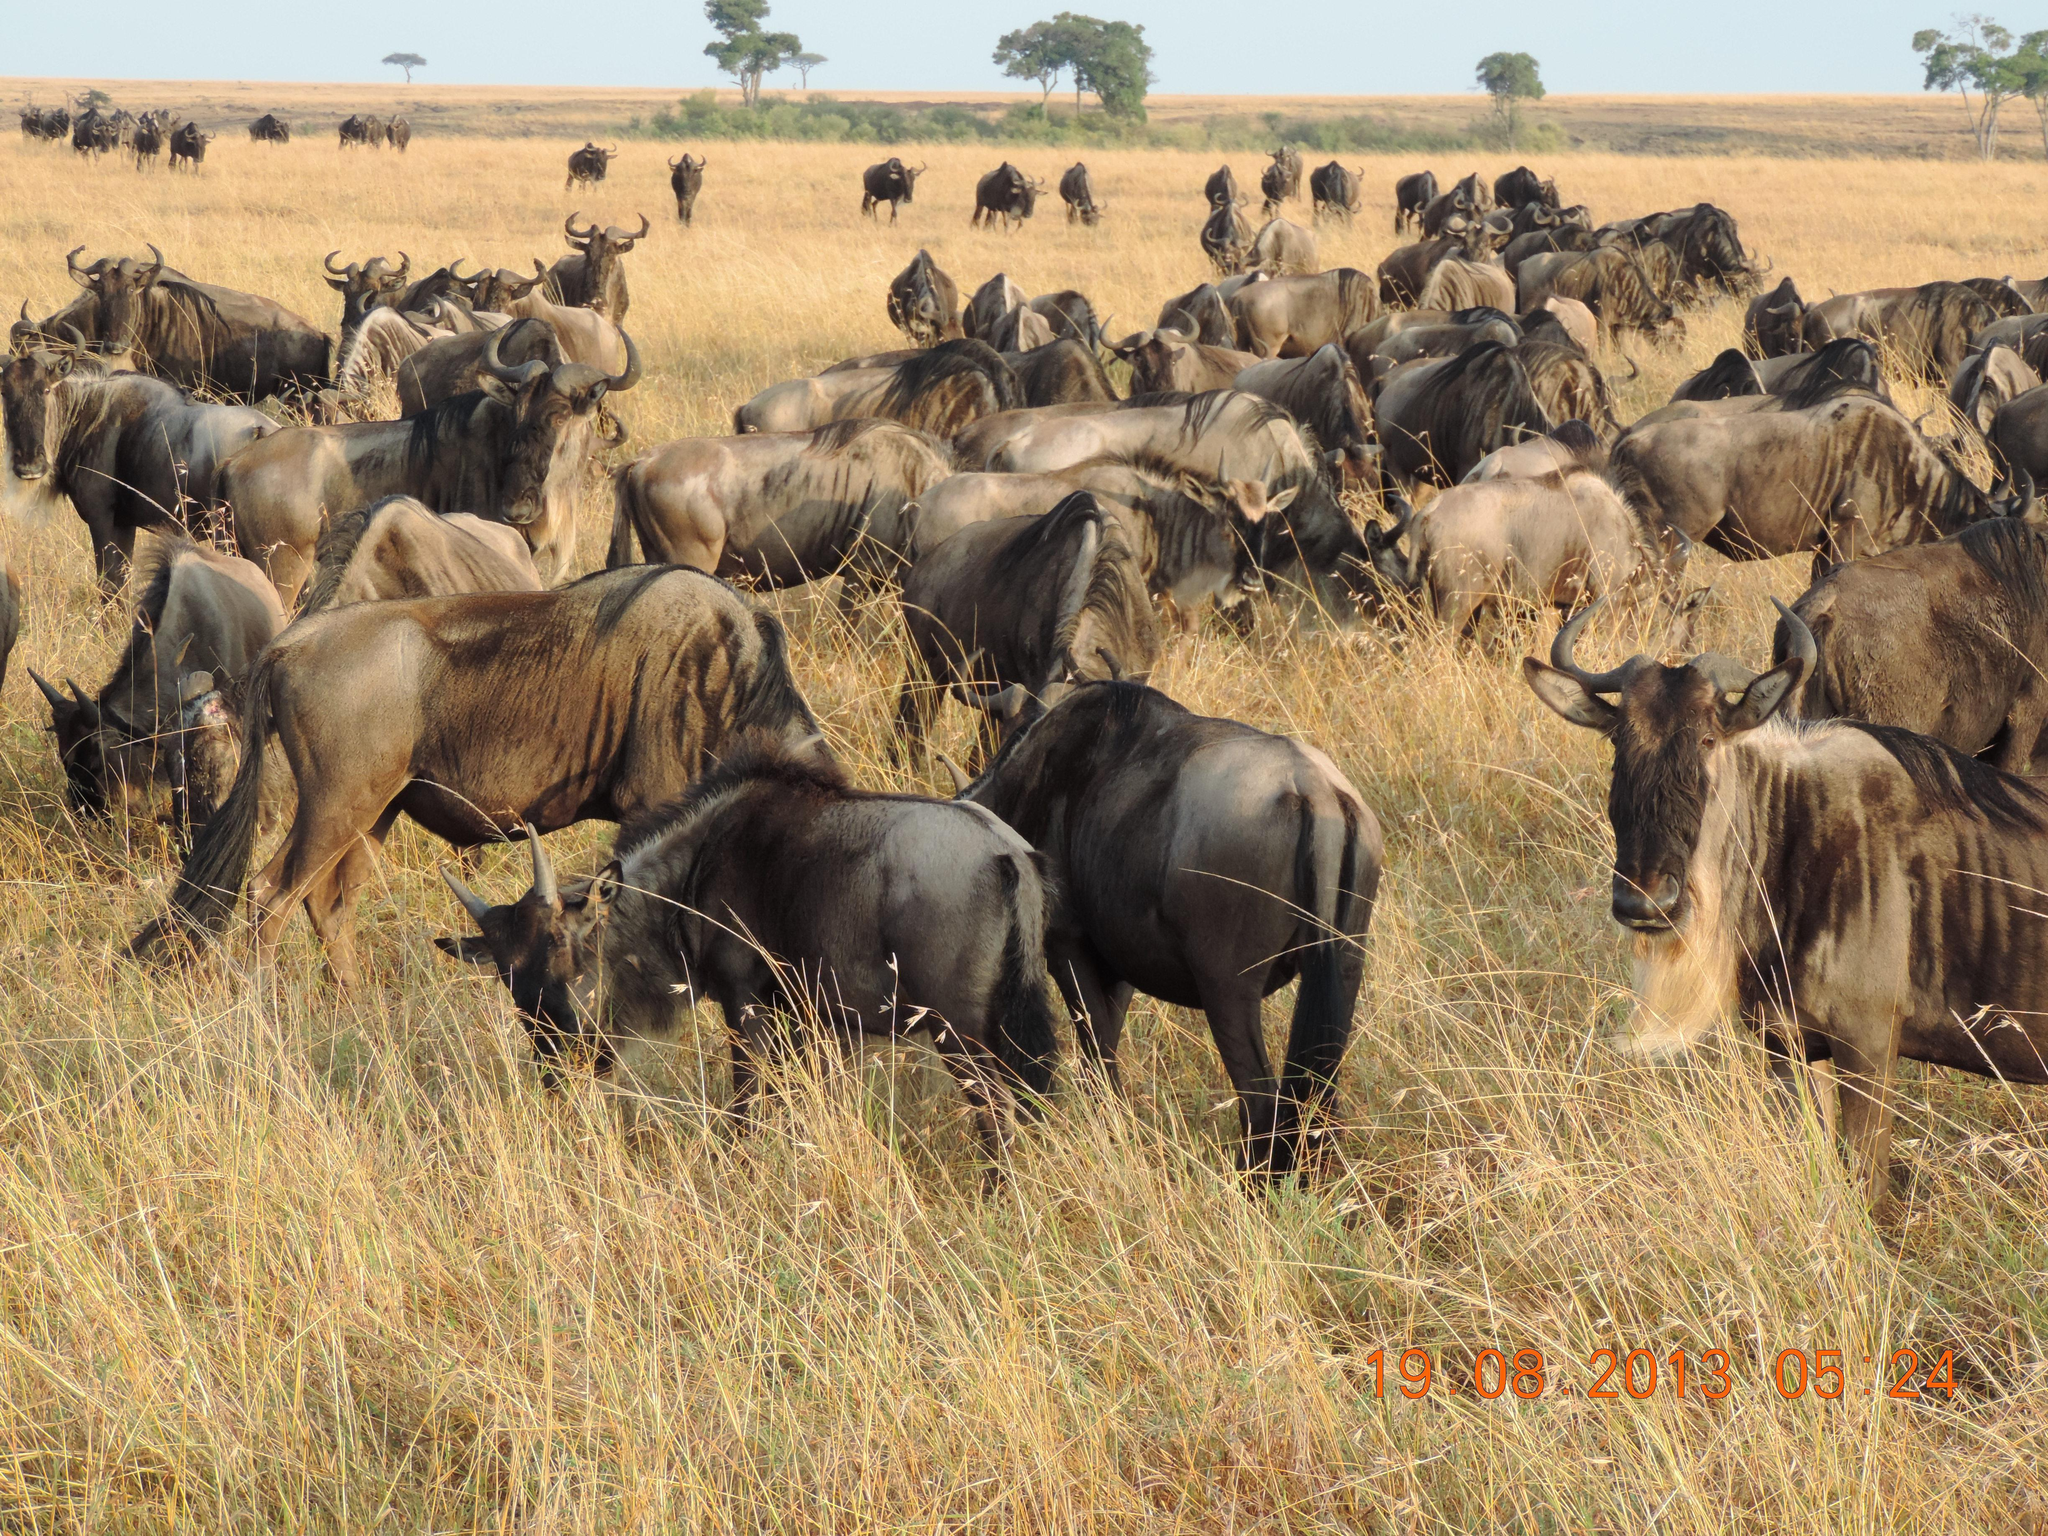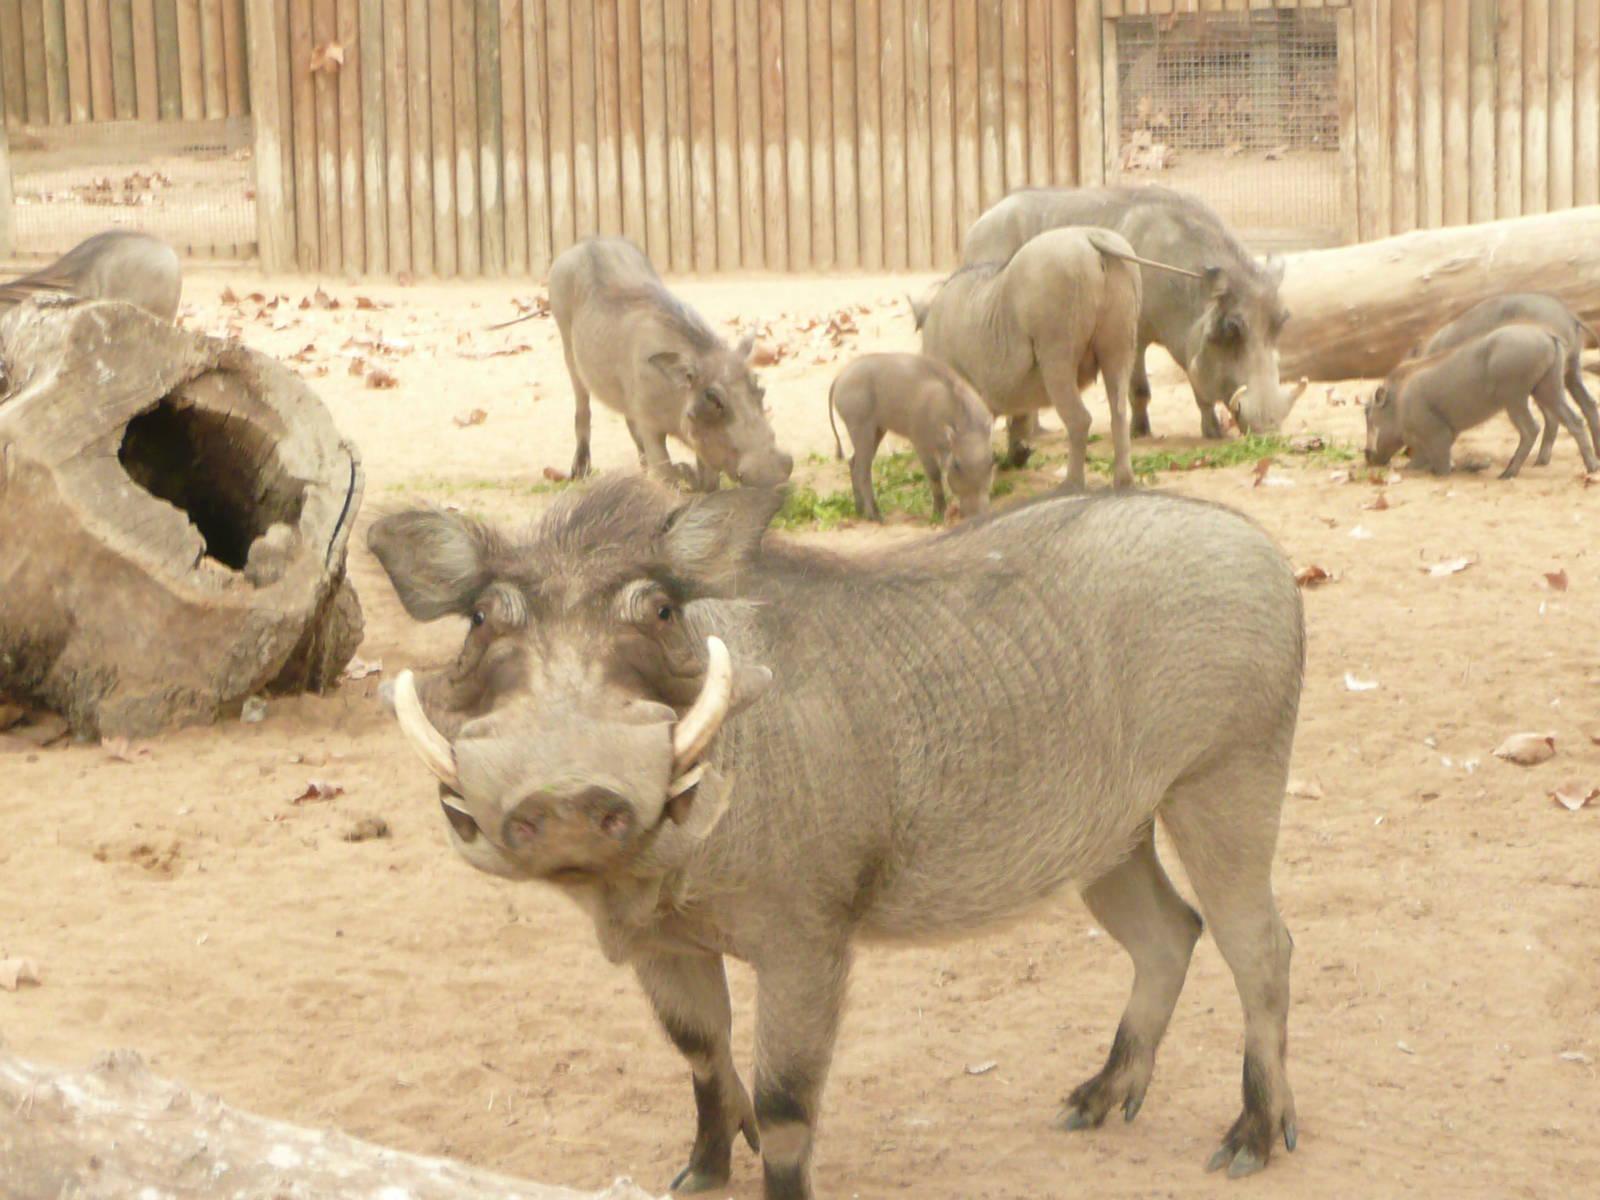The first image is the image on the left, the second image is the image on the right. For the images displayed, is the sentence "In one of the images there is a group of warthogs standing near water." factually correct? Answer yes or no. No. 